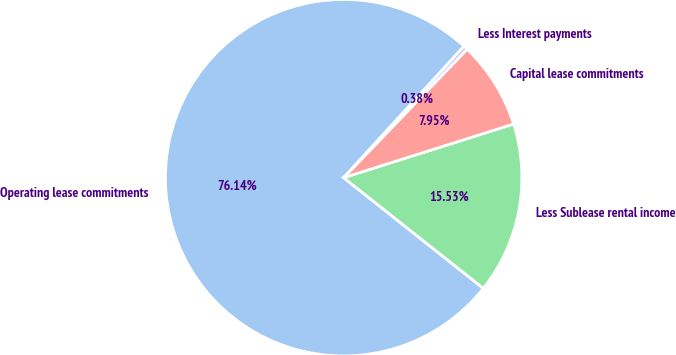Convert chart. <chart><loc_0><loc_0><loc_500><loc_500><pie_chart><fcel>Operating lease commitments<fcel>Less Sublease rental income<fcel>Capital lease commitments<fcel>Less Interest payments<nl><fcel>76.14%<fcel>15.53%<fcel>7.95%<fcel>0.38%<nl></chart> 